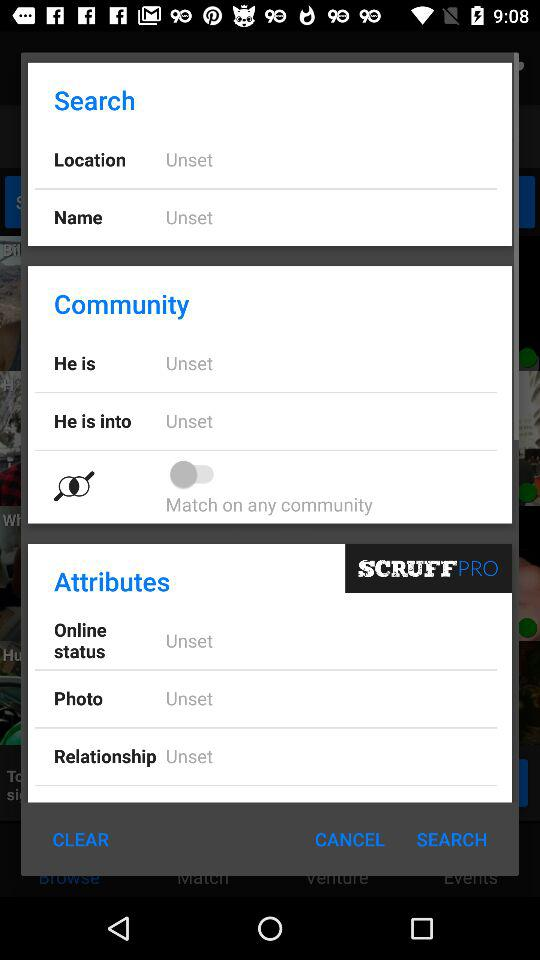What is the status of "Match on any community"? The status of "Match on any community" is "off". 